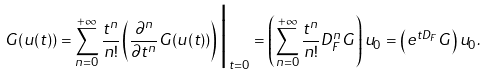Convert formula to latex. <formula><loc_0><loc_0><loc_500><loc_500>G ( u ( t ) ) = \sum _ { n = 0 } ^ { + \infty } \frac { t ^ { n } } { n ! } \left ( \frac { \partial ^ { n } } { \partial t ^ { n } } G ( u ( t ) ) \right ) \Big | _ { t = 0 } = \left ( \sum _ { n = 0 } ^ { + \infty } \frac { t ^ { n } } { n ! } D ^ { n } _ { F } G \right ) u _ { 0 } = \left ( e ^ { t D _ { F } } G \right ) u _ { 0 } .</formula> 